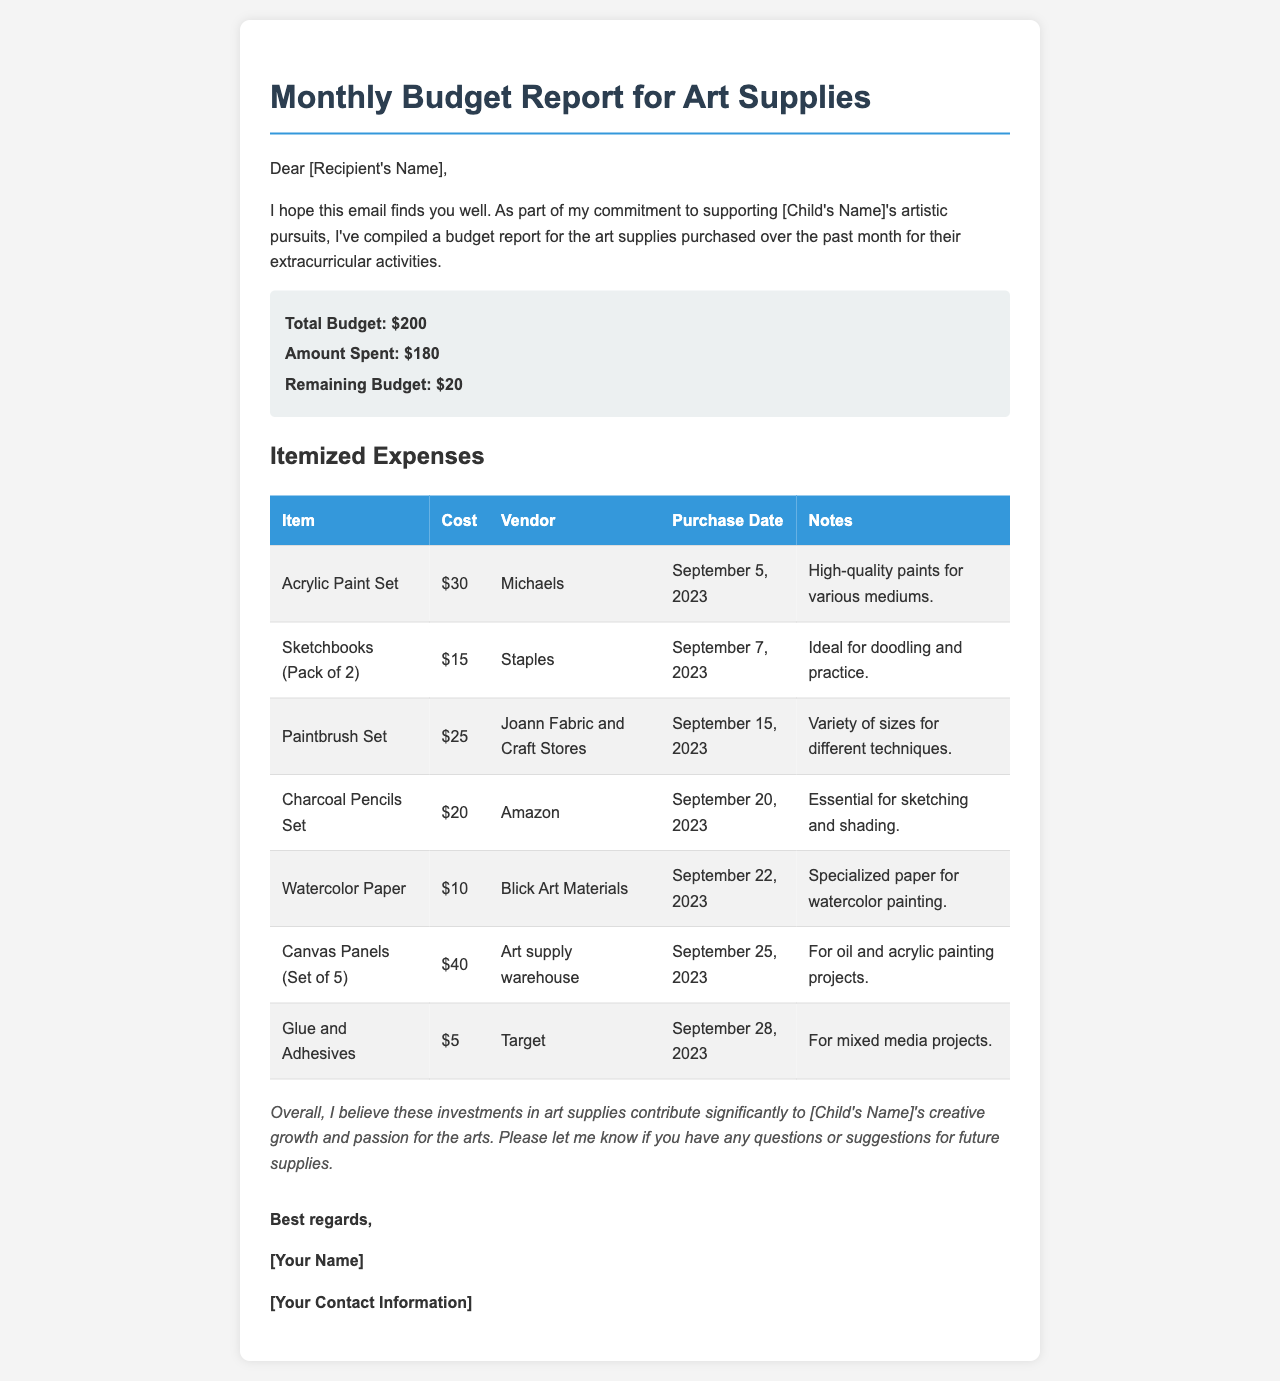What is the total budget for art supplies? The total budget is stated clearly in the report as $200.
Answer: $200 How much was spent on art supplies? The amount spent is detailed in the budget summary as $180.
Answer: $180 What is the remaining budget? The remaining budget is calculated by subtracting the amount spent from the total budget, which is $20.
Answer: $20 What was the purchase date for the Acrylic Paint Set? The document specifies that the Acrylic Paint Set was purchased on September 5, 2023.
Answer: September 5, 2023 Which vendor sold the Paintbrush Set? The vendor for the Paintbrush Set is mentioned as Joann Fabric and Craft Stores.
Answer: Joann Fabric and Craft Stores How many items were listed in the itemized expenses? The document lists a total of 7 different items in the table of expenses.
Answer: 7 What is the purpose of the Watercolor Paper? The document notes that the Watercolor Paper is specialized for watercolor painting.
Answer: Watercolor painting What is the total cost of the Sketchbooks? The cost for the Sketchbooks (Pack of 2) is provided as $15.
Answer: $15 What conclusion does the author make about the expenses? The author believes these expenses contribute significantly to the child's creative growth.
Answer: Creative growth 